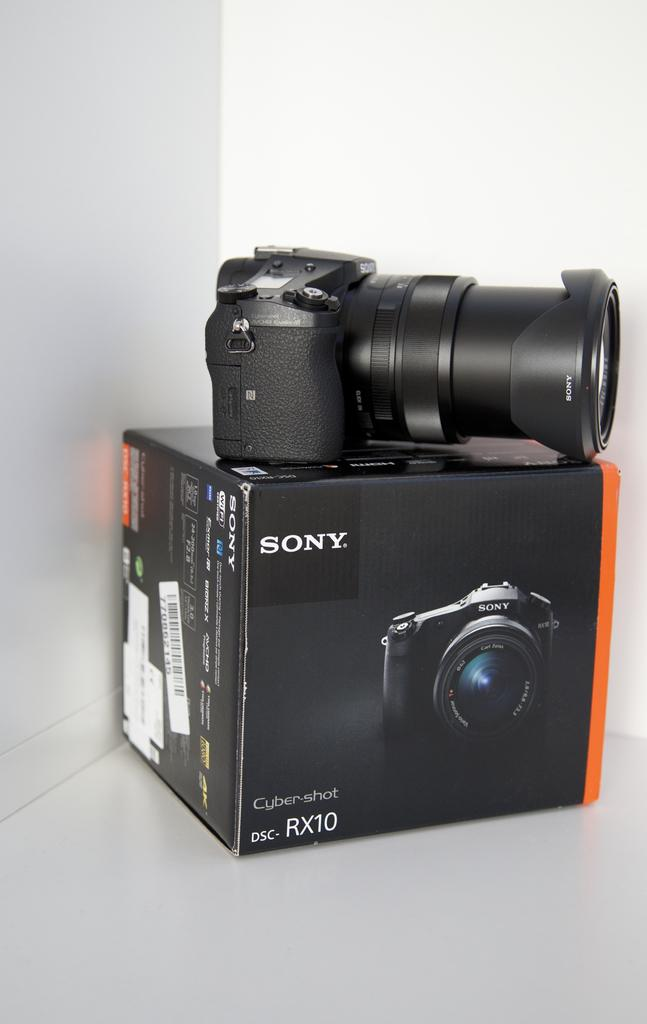What is the main object in the image? There is a camera in the image. Where is the camera placed? The camera is placed on a camera box. What can be seen in the background of the image? There is a white color wall in the background of the image. How many snakes are slithering on the camera box in the image? There are no snakes present in the image; the camera is placed on a camera box. 